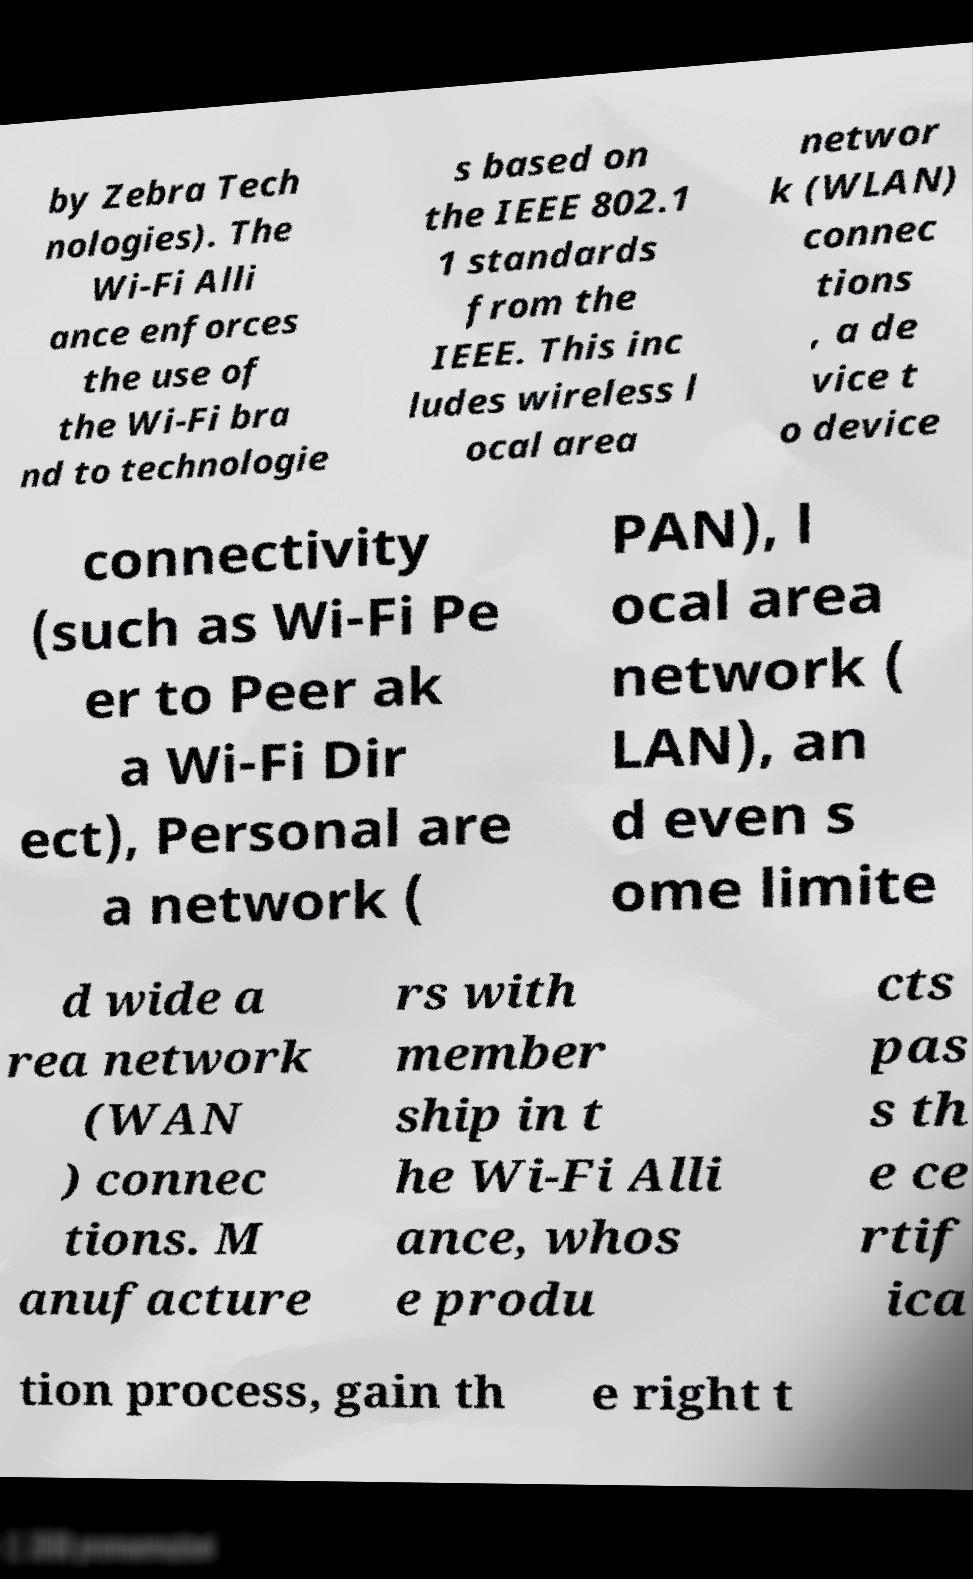I need the written content from this picture converted into text. Can you do that? by Zebra Tech nologies). The Wi-Fi Alli ance enforces the use of the Wi-Fi bra nd to technologie s based on the IEEE 802.1 1 standards from the IEEE. This inc ludes wireless l ocal area networ k (WLAN) connec tions , a de vice t o device connectivity (such as Wi-Fi Pe er to Peer ak a Wi-Fi Dir ect), Personal are a network ( PAN), l ocal area network ( LAN), an d even s ome limite d wide a rea network (WAN ) connec tions. M anufacture rs with member ship in t he Wi-Fi Alli ance, whos e produ cts pas s th e ce rtif ica tion process, gain th e right t 